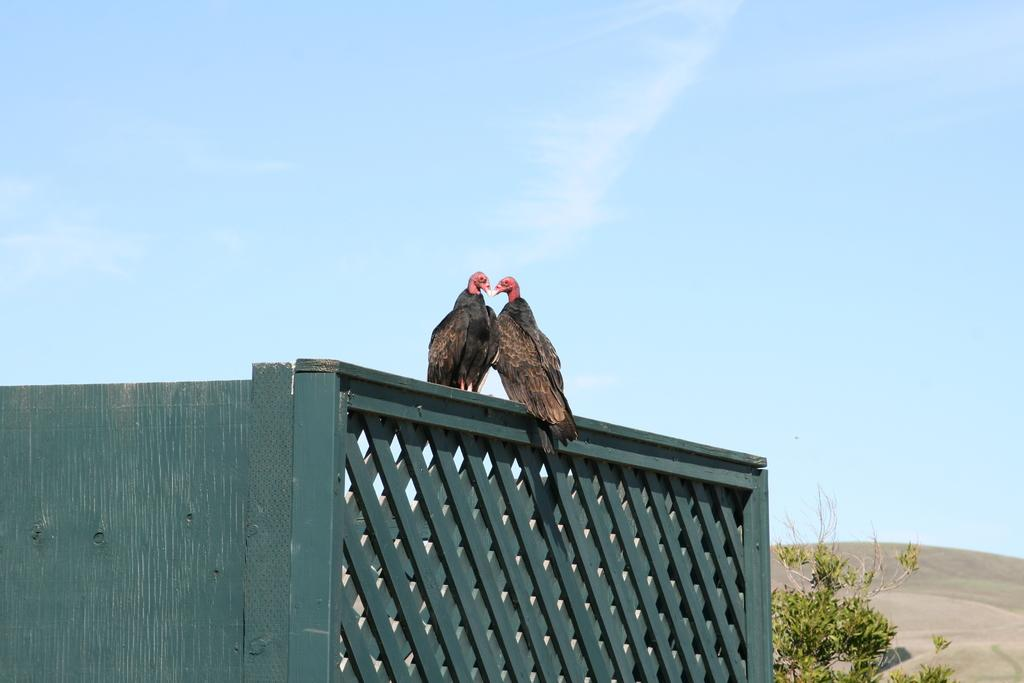What material is the wall in the image made of? The wall in the image is made of wood. What animals are on the wooden wall? There are two vultures on the wooden wall. What is located near the wooden wall? There is a tree near the wooden wall. What can be seen in the background of the image? The sky is visible in the background of the image. What type of yak can be seen walking down the street in the image? There is no yak or street present in the image; it features a wooden wall with vultures and a tree. 